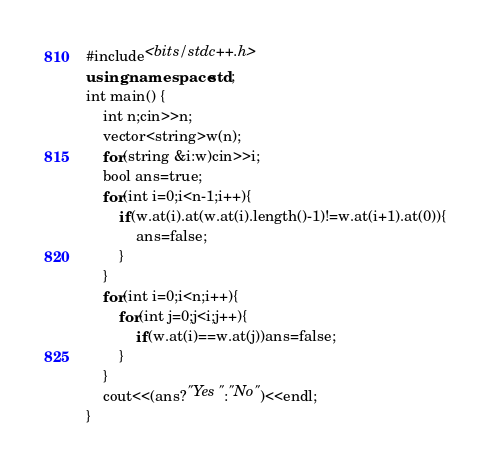Convert code to text. <code><loc_0><loc_0><loc_500><loc_500><_C++_>#include<bits/stdc++.h>
using namespace std;
int main() {
    int n;cin>>n;
    vector<string>w(n);
    for(string &i:w)cin>>i;
    bool ans=true;
    for(int i=0;i<n-1;i++){
        if(w.at(i).at(w.at(i).length()-1)!=w.at(i+1).at(0)){
            ans=false;
        }
    }
    for(int i=0;i<n;i++){
        for(int j=0;j<i;j++){
            if(w.at(i)==w.at(j))ans=false;
        }
    }
    cout<<(ans?"Yes":"No")<<endl;
}</code> 